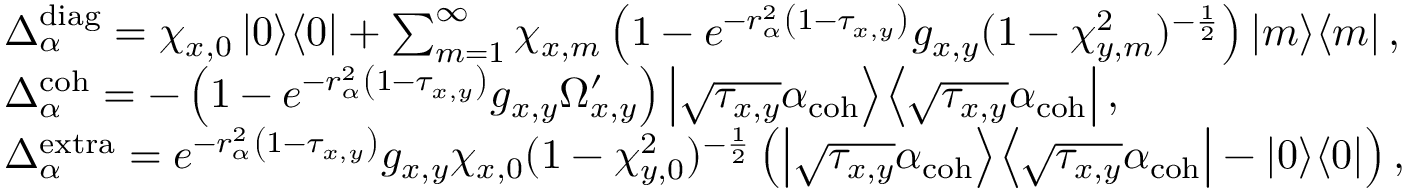Convert formula to latex. <formula><loc_0><loc_0><loc_500><loc_500>\begin{array} { r l } & { \Delta _ { \alpha } ^ { d i a g } = \chi _ { x , 0 } \left | 0 | d l e > | d l e < 0 \right | + \sum _ { m = 1 } ^ { \infty } \chi _ { x , m } \left ( 1 - e ^ { - r _ { \alpha } ^ { 2 } \left ( 1 - \tau _ { x , y } \right ) } g _ { x , y } ( 1 - \chi _ { y , m } ^ { 2 } ) ^ { - \frac { 1 } { 2 } } \right ) \left | m | d l e > | d l e < m \right | , } \\ & { \Delta _ { \alpha } ^ { c o h } = - \left ( 1 - e ^ { - r _ { \alpha } ^ { 2 } \left ( 1 - \tau _ { x , y } \right ) } g _ { x , y } \Omega _ { x , y } ^ { \prime } \right ) \left | \sqrt { \tau _ { x , y } } \alpha _ { c o h } | d l e > | d l e < \sqrt { \tau _ { x , y } } \alpha _ { c o h } \right | , } \\ & { \Delta _ { \alpha } ^ { e x t r a } = e ^ { - r _ { \alpha } ^ { 2 } \left ( 1 - \tau _ { x , y } \right ) } g _ { x , y } \chi _ { x , 0 } ( 1 - \chi _ { y , 0 } ^ { 2 } ) ^ { - \frac { 1 } { 2 } } \left ( \left | \sqrt { \tau _ { x , y } } \alpha _ { c o h } | d l e > | d l e < \sqrt { \tau _ { x , y } } \alpha _ { c o h } \right | - \left | 0 | d l e > | d l e < 0 \right | \right ) , } \end{array}</formula> 